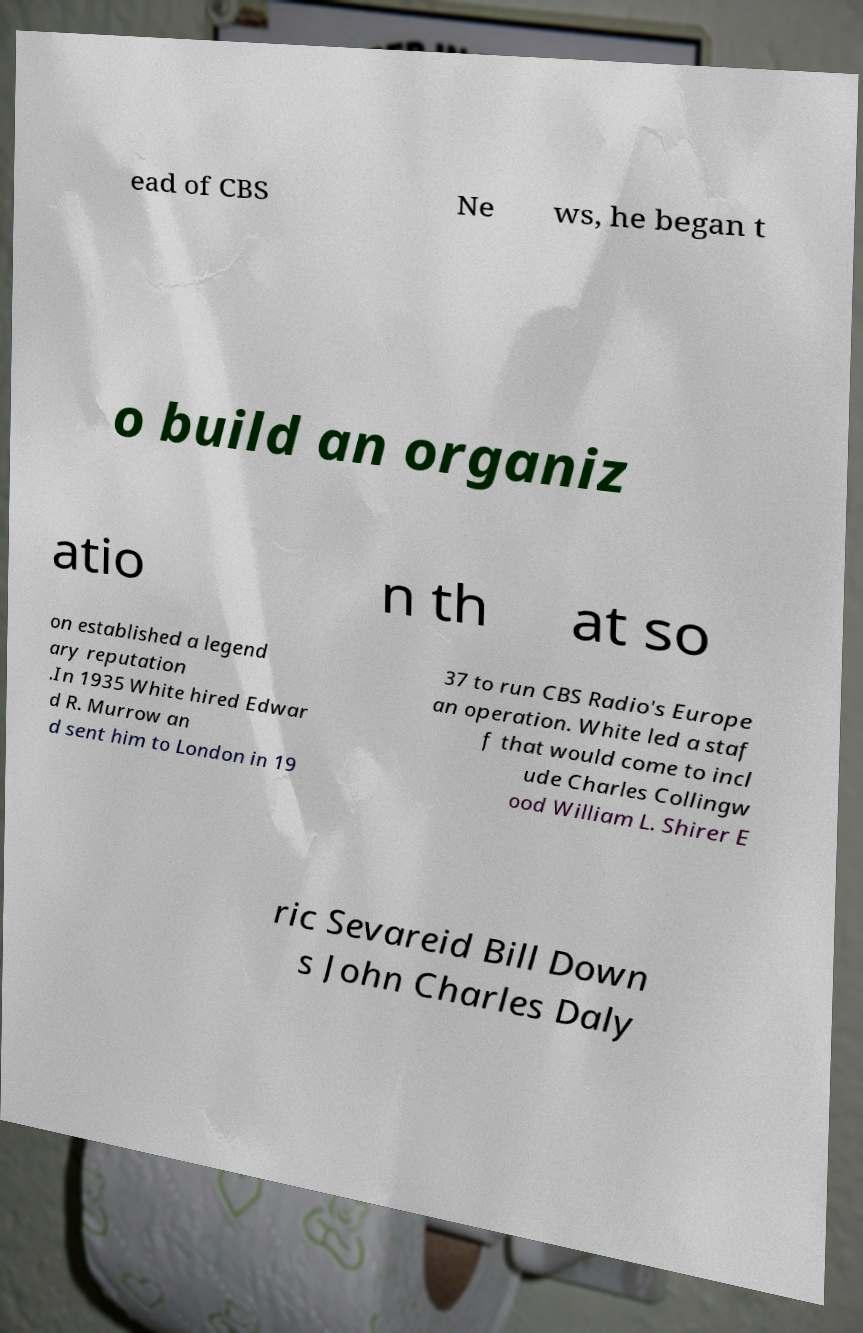There's text embedded in this image that I need extracted. Can you transcribe it verbatim? ead of CBS Ne ws, he began t o build an organiz atio n th at so on established a legend ary reputation .In 1935 White hired Edwar d R. Murrow an d sent him to London in 19 37 to run CBS Radio's Europe an operation. White led a staf f that would come to incl ude Charles Collingw ood William L. Shirer E ric Sevareid Bill Down s John Charles Daly 